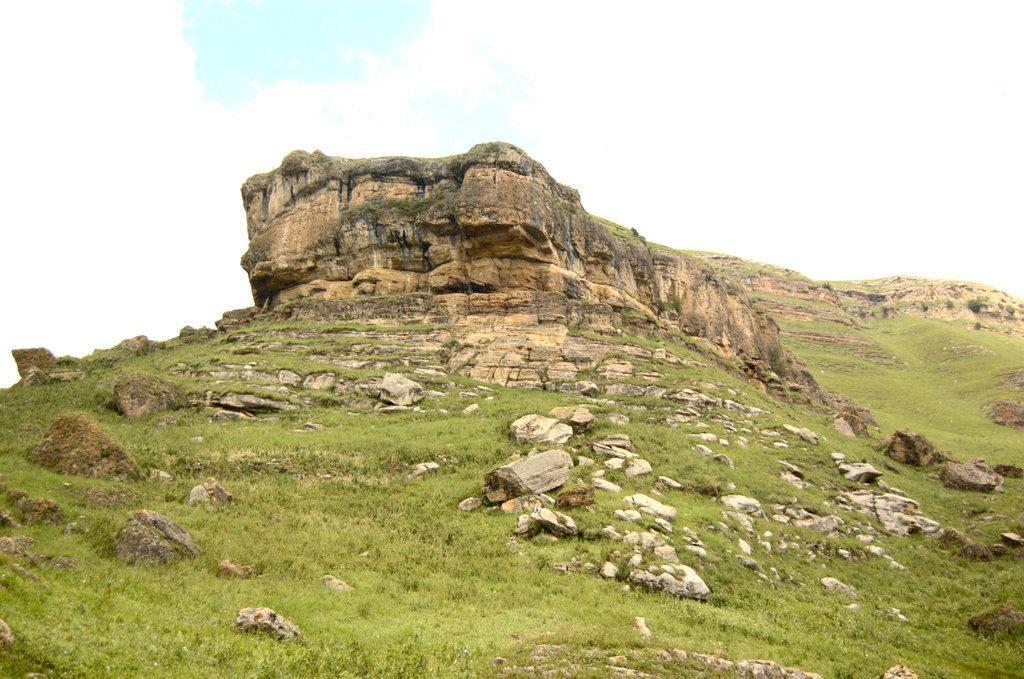Please provide a concise description of this image. In the center of the image we can see a mountain. There are stones, grass. At the top of the image there is sky. 